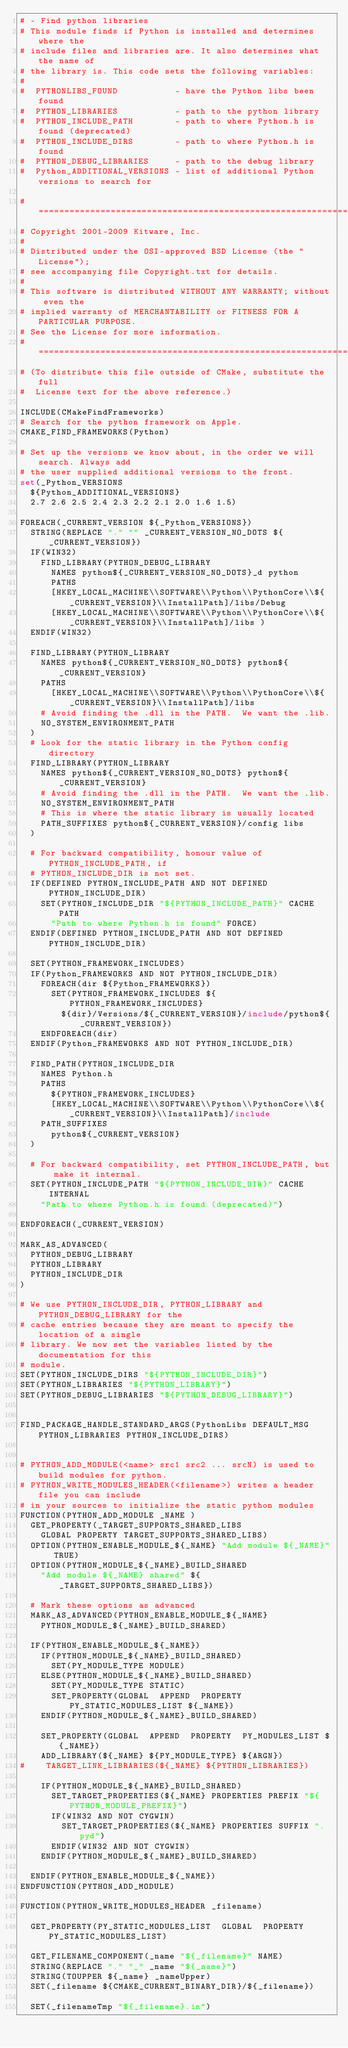<code> <loc_0><loc_0><loc_500><loc_500><_CMake_># - Find python libraries
# This module finds if Python is installed and determines where the
# include files and libraries are. It also determines what the name of
# the library is. This code sets the following variables:
#
#  PYTHONLIBS_FOUND           - have the Python libs been found
#  PYTHON_LIBRARIES           - path to the python library
#  PYTHON_INCLUDE_PATH        - path to where Python.h is found (deprecated)
#  PYTHON_INCLUDE_DIRS        - path to where Python.h is found
#  PYTHON_DEBUG_LIBRARIES     - path to the debug library
#  Python_ADDITIONAL_VERSIONS - list of additional Python versions to search for

#=============================================================================
# Copyright 2001-2009 Kitware, Inc.
#
# Distributed under the OSI-approved BSD License (the "License");
# see accompanying file Copyright.txt for details.
#
# This software is distributed WITHOUT ANY WARRANTY; without even the
# implied warranty of MERCHANTABILITY or FITNESS FOR A PARTICULAR PURPOSE.
# See the License for more information.
#=============================================================================
# (To distribute this file outside of CMake, substitute the full
#  License text for the above reference.)

INCLUDE(CMakeFindFrameworks)
# Search for the python framework on Apple.
CMAKE_FIND_FRAMEWORKS(Python)

# Set up the versions we know about, in the order we will search. Always add
# the user supplied additional versions to the front.
set(_Python_VERSIONS
  ${Python_ADDITIONAL_VERSIONS}
  2.7 2.6 2.5 2.4 2.3 2.2 2.1 2.0 1.6 1.5)

FOREACH(_CURRENT_VERSION ${_Python_VERSIONS})
  STRING(REPLACE "." "" _CURRENT_VERSION_NO_DOTS ${_CURRENT_VERSION})
  IF(WIN32)
    FIND_LIBRARY(PYTHON_DEBUG_LIBRARY
      NAMES python${_CURRENT_VERSION_NO_DOTS}_d python
      PATHS
      [HKEY_LOCAL_MACHINE\\SOFTWARE\\Python\\PythonCore\\${_CURRENT_VERSION}\\InstallPath]/libs/Debug
      [HKEY_LOCAL_MACHINE\\SOFTWARE\\Python\\PythonCore\\${_CURRENT_VERSION}\\InstallPath]/libs )
  ENDIF(WIN32)

  FIND_LIBRARY(PYTHON_LIBRARY
    NAMES python${_CURRENT_VERSION_NO_DOTS} python${_CURRENT_VERSION}
    PATHS
      [HKEY_LOCAL_MACHINE\\SOFTWARE\\Python\\PythonCore\\${_CURRENT_VERSION}\\InstallPath]/libs
    # Avoid finding the .dll in the PATH.  We want the .lib.
    NO_SYSTEM_ENVIRONMENT_PATH
  )
  # Look for the static library in the Python config directory
  FIND_LIBRARY(PYTHON_LIBRARY
    NAMES python${_CURRENT_VERSION_NO_DOTS} python${_CURRENT_VERSION}
    # Avoid finding the .dll in the PATH.  We want the .lib.
    NO_SYSTEM_ENVIRONMENT_PATH
    # This is where the static library is usually located
    PATH_SUFFIXES python${_CURRENT_VERSION}/config libs
  )

  # For backward compatibility, honour value of PYTHON_INCLUDE_PATH, if
  # PYTHON_INCLUDE_DIR is not set.
  IF(DEFINED PYTHON_INCLUDE_PATH AND NOT DEFINED PYTHON_INCLUDE_DIR)
    SET(PYTHON_INCLUDE_DIR "${PYTHON_INCLUDE_PATH}" CACHE PATH
      "Path to where Python.h is found" FORCE)
  ENDIF(DEFINED PYTHON_INCLUDE_PATH AND NOT DEFINED PYTHON_INCLUDE_DIR)

  SET(PYTHON_FRAMEWORK_INCLUDES)
  IF(Python_FRAMEWORKS AND NOT PYTHON_INCLUDE_DIR)
    FOREACH(dir ${Python_FRAMEWORKS})
      SET(PYTHON_FRAMEWORK_INCLUDES ${PYTHON_FRAMEWORK_INCLUDES}
        ${dir}/Versions/${_CURRENT_VERSION}/include/python${_CURRENT_VERSION})
    ENDFOREACH(dir)
  ENDIF(Python_FRAMEWORKS AND NOT PYTHON_INCLUDE_DIR)

  FIND_PATH(PYTHON_INCLUDE_DIR
    NAMES Python.h
    PATHS
      ${PYTHON_FRAMEWORK_INCLUDES}
      [HKEY_LOCAL_MACHINE\\SOFTWARE\\Python\\PythonCore\\${_CURRENT_VERSION}\\InstallPath]/include
    PATH_SUFFIXES
      python${_CURRENT_VERSION}
  )

  # For backward compatibility, set PYTHON_INCLUDE_PATH, but make it internal.
  SET(PYTHON_INCLUDE_PATH "${PYTHON_INCLUDE_DIR}" CACHE INTERNAL
    "Path to where Python.h is found (deprecated)")

ENDFOREACH(_CURRENT_VERSION)

MARK_AS_ADVANCED(
  PYTHON_DEBUG_LIBRARY
  PYTHON_LIBRARY
  PYTHON_INCLUDE_DIR
)

# We use PYTHON_INCLUDE_DIR, PYTHON_LIBRARY and PYTHON_DEBUG_LIBRARY for the
# cache entries because they are meant to specify the location of a single
# library. We now set the variables listed by the documentation for this
# module.
SET(PYTHON_INCLUDE_DIRS "${PYTHON_INCLUDE_DIR}")
SET(PYTHON_LIBRARIES "${PYTHON_LIBRARY}")
SET(PYTHON_DEBUG_LIBRARIES "${PYTHON_DEBUG_LIBRARY}")


FIND_PACKAGE_HANDLE_STANDARD_ARGS(PythonLibs DEFAULT_MSG PYTHON_LIBRARIES PYTHON_INCLUDE_DIRS)


# PYTHON_ADD_MODULE(<name> src1 src2 ... srcN) is used to build modules for python.
# PYTHON_WRITE_MODULES_HEADER(<filename>) writes a header file you can include
# in your sources to initialize the static python modules
FUNCTION(PYTHON_ADD_MODULE _NAME )
  GET_PROPERTY(_TARGET_SUPPORTS_SHARED_LIBS
    GLOBAL PROPERTY TARGET_SUPPORTS_SHARED_LIBS)
  OPTION(PYTHON_ENABLE_MODULE_${_NAME} "Add module ${_NAME}" TRUE)
  OPTION(PYTHON_MODULE_${_NAME}_BUILD_SHARED
    "Add module ${_NAME} shared" ${_TARGET_SUPPORTS_SHARED_LIBS})

  # Mark these options as advanced
  MARK_AS_ADVANCED(PYTHON_ENABLE_MODULE_${_NAME}
    PYTHON_MODULE_${_NAME}_BUILD_SHARED)

  IF(PYTHON_ENABLE_MODULE_${_NAME})
    IF(PYTHON_MODULE_${_NAME}_BUILD_SHARED)
      SET(PY_MODULE_TYPE MODULE)
    ELSE(PYTHON_MODULE_${_NAME}_BUILD_SHARED)
      SET(PY_MODULE_TYPE STATIC)
      SET_PROPERTY(GLOBAL  APPEND  PROPERTY  PY_STATIC_MODULES_LIST ${_NAME})
    ENDIF(PYTHON_MODULE_${_NAME}_BUILD_SHARED)

    SET_PROPERTY(GLOBAL  APPEND  PROPERTY  PY_MODULES_LIST ${_NAME})
    ADD_LIBRARY(${_NAME} ${PY_MODULE_TYPE} ${ARGN})
#    TARGET_LINK_LIBRARIES(${_NAME} ${PYTHON_LIBRARIES})

    IF(PYTHON_MODULE_${_NAME}_BUILD_SHARED)
      SET_TARGET_PROPERTIES(${_NAME} PROPERTIES PREFIX "${PYTHON_MODULE_PREFIX}")
      IF(WIN32 AND NOT CYGWIN)
        SET_TARGET_PROPERTIES(${_NAME} PROPERTIES SUFFIX ".pyd")
      ENDIF(WIN32 AND NOT CYGWIN)
    ENDIF(PYTHON_MODULE_${_NAME}_BUILD_SHARED)

  ENDIF(PYTHON_ENABLE_MODULE_${_NAME})
ENDFUNCTION(PYTHON_ADD_MODULE)

FUNCTION(PYTHON_WRITE_MODULES_HEADER _filename)

  GET_PROPERTY(PY_STATIC_MODULES_LIST  GLOBAL  PROPERTY PY_STATIC_MODULES_LIST)

  GET_FILENAME_COMPONENT(_name "${_filename}" NAME)
  STRING(REPLACE "." "_" _name "${_name}")
  STRING(TOUPPER ${_name} _nameUpper)
  SET(_filename ${CMAKE_CURRENT_BINARY_DIR}/${_filename})

  SET(_filenameTmp "${_filename}.in")</code> 